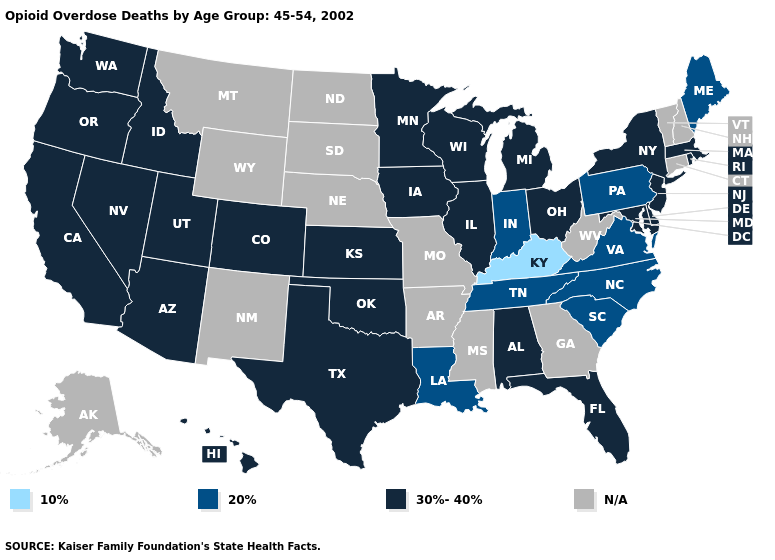Which states have the lowest value in the USA?
Write a very short answer. Kentucky. What is the value of California?
Keep it brief. 30%-40%. Does the map have missing data?
Write a very short answer. Yes. Does Minnesota have the lowest value in the USA?
Quick response, please. No. Name the states that have a value in the range 30%-40%?
Keep it brief. Alabama, Arizona, California, Colorado, Delaware, Florida, Hawaii, Idaho, Illinois, Iowa, Kansas, Maryland, Massachusetts, Michigan, Minnesota, Nevada, New Jersey, New York, Ohio, Oklahoma, Oregon, Rhode Island, Texas, Utah, Washington, Wisconsin. What is the lowest value in the Northeast?
Give a very brief answer. 20%. What is the value of Minnesota?
Concise answer only. 30%-40%. Name the states that have a value in the range 30%-40%?
Be succinct. Alabama, Arizona, California, Colorado, Delaware, Florida, Hawaii, Idaho, Illinois, Iowa, Kansas, Maryland, Massachusetts, Michigan, Minnesota, Nevada, New Jersey, New York, Ohio, Oklahoma, Oregon, Rhode Island, Texas, Utah, Washington, Wisconsin. Does Maine have the highest value in the Northeast?
Be succinct. No. Which states hav the highest value in the Northeast?
Give a very brief answer. Massachusetts, New Jersey, New York, Rhode Island. Among the states that border California , which have the lowest value?
Quick response, please. Arizona, Nevada, Oregon. Name the states that have a value in the range 10%?
Give a very brief answer. Kentucky. Does Nevada have the highest value in the USA?
Concise answer only. Yes. What is the value of Washington?
Answer briefly. 30%-40%. What is the lowest value in the MidWest?
Be succinct. 20%. 